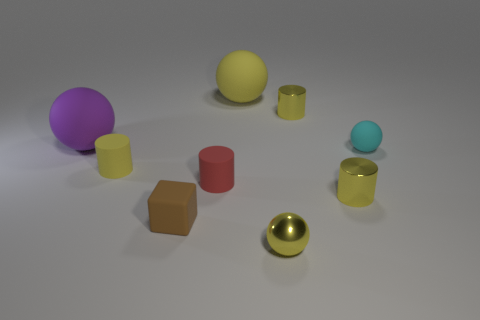Subtract all yellow blocks. How many yellow cylinders are left? 3 Subtract 1 cylinders. How many cylinders are left? 3 Subtract all gray spheres. Subtract all purple cubes. How many spheres are left? 4 Subtract all cylinders. How many objects are left? 5 Add 9 brown matte objects. How many brown matte objects exist? 10 Subtract 0 green cylinders. How many objects are left? 9 Subtract all tiny yellow cylinders. Subtract all purple matte things. How many objects are left? 5 Add 1 metallic balls. How many metallic balls are left? 2 